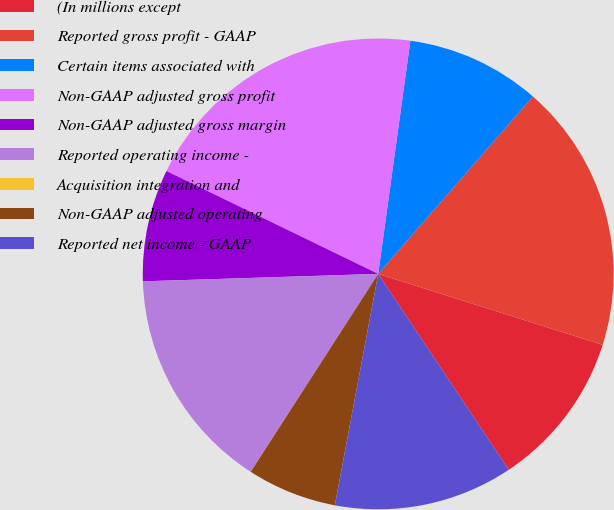Convert chart. <chart><loc_0><loc_0><loc_500><loc_500><pie_chart><fcel>(In millions except<fcel>Reported gross profit - GAAP<fcel>Certain items associated with<fcel>Non-GAAP adjusted gross profit<fcel>Non-GAAP adjusted gross margin<fcel>Reported operating income -<fcel>Acquisition integration and<fcel>Non-GAAP adjusted operating<fcel>Reported net income - GAAP<nl><fcel>10.77%<fcel>18.46%<fcel>9.23%<fcel>19.99%<fcel>7.7%<fcel>15.38%<fcel>0.01%<fcel>6.16%<fcel>12.31%<nl></chart> 